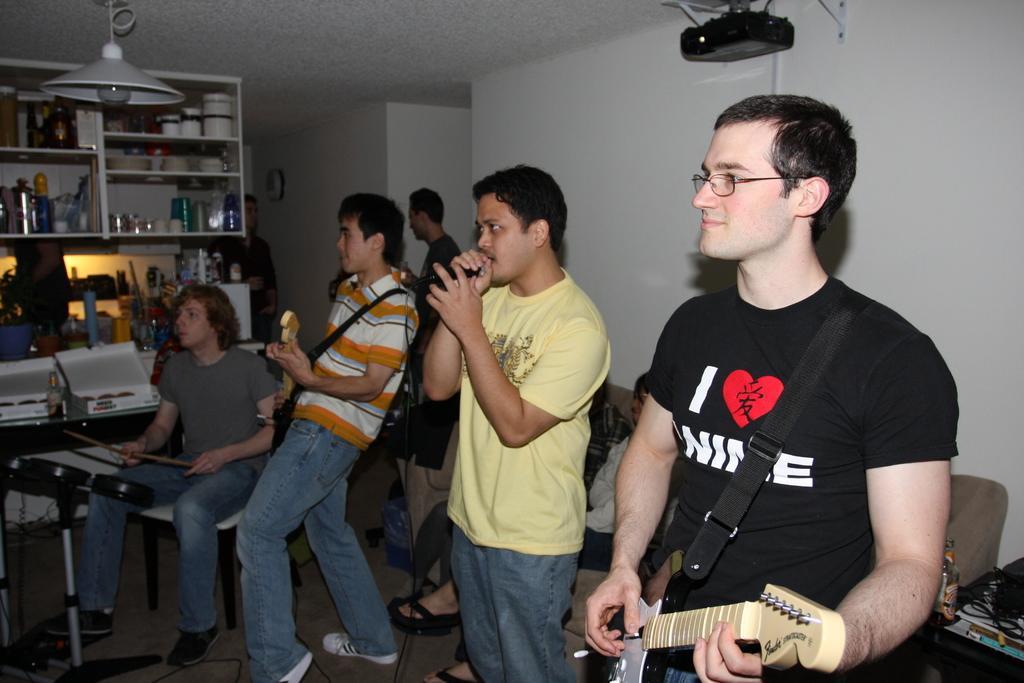Please provide a concise description of this image. There are four members in the given picture. Three of them was standing. One guy is singing with the Mike in his hand. Three of them were playing musical instruments. In the background there is a shelf in which some accessories were placed. We can observe a man in the background. Here there is a projector attached to the ceiling. 